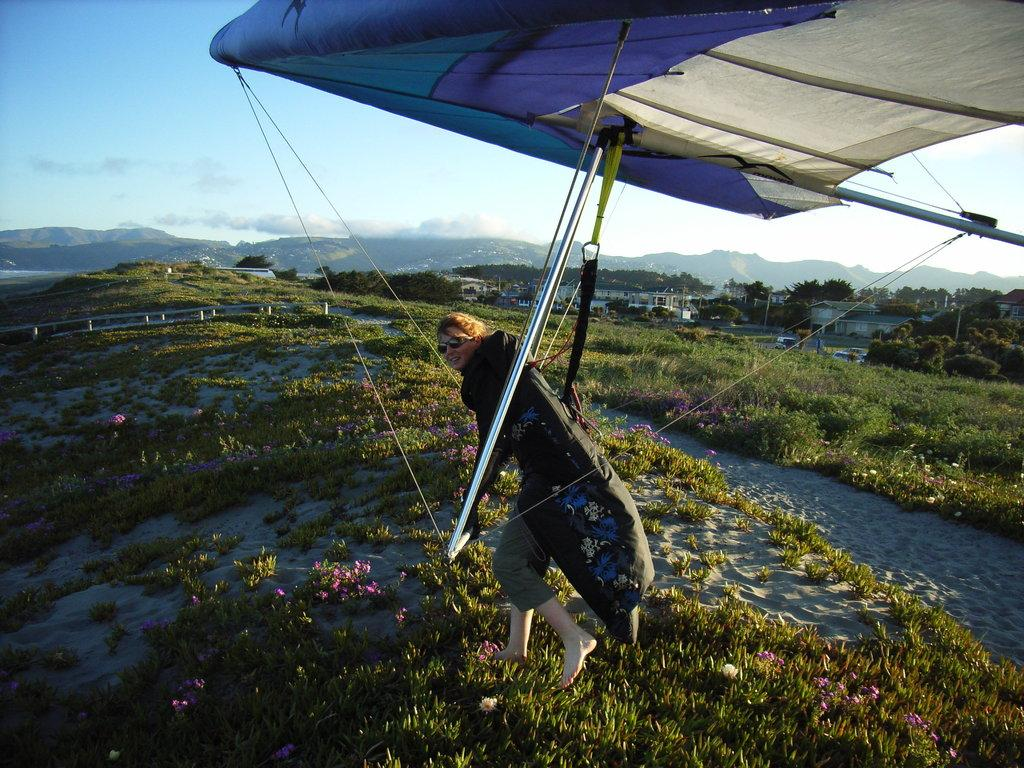What type of vegetation is present in the image? There is grass in the image. What is the person in the image holding? The person is holding a parachute in the image. What other natural elements can be seen in the image? There are trees in the image. What man-made structures are visible in the image? There are buildings in the image. What type of terrain is present in the image? There are hills in the image. What is visible at the top of the image? The sky is visible at the top of the image. What type of calculator is the person using while holding the parachute in the image? There is no calculator present in the image; the person is simply holding a parachute. What type of vacation destination is depicted in the image? The image does not depict a specific vacation destination; it shows a person holding a parachute, grass, trees, buildings, hills, and the sky. 